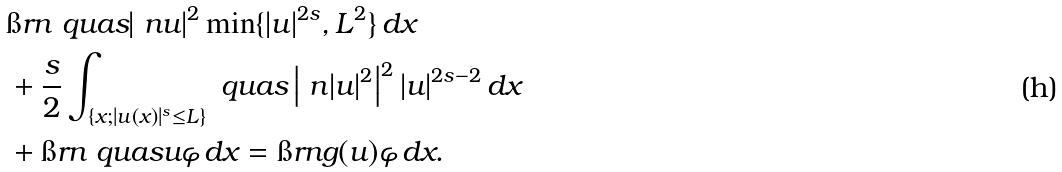Convert formula to latex. <formula><loc_0><loc_0><loc_500><loc_500>& \i r n \ q u a s | \ n u | ^ { 2 } \min \{ | u | ^ { 2 s } , L ^ { 2 } \} \, d x \\ & + \frac { s } { 2 } \int _ { \{ x ; | u ( x ) | ^ { s } \leq L \} } \ q u a s \left | \ n | u | ^ { 2 } \right | ^ { 2 } | u | ^ { 2 s - 2 } \, d x \\ & + \i r n \ q u a s u \varphi \, d x = \i r n g ( u ) \varphi \, d x .</formula> 